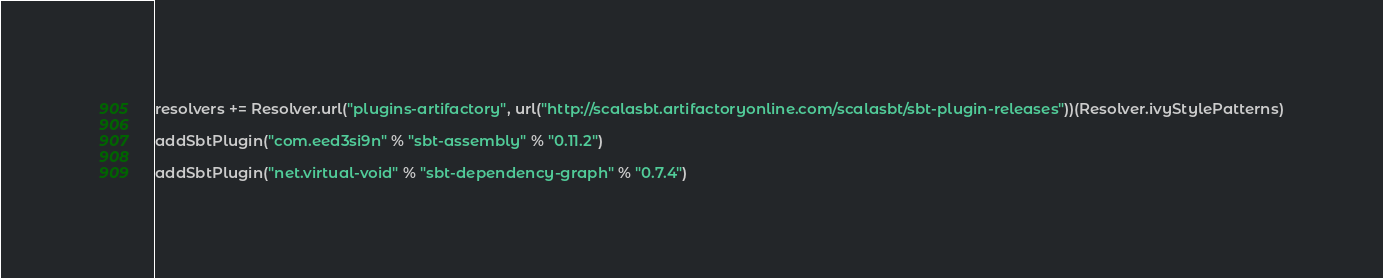Convert code to text. <code><loc_0><loc_0><loc_500><loc_500><_Scala_>resolvers += Resolver.url("plugins-artifactory", url("http://scalasbt.artifactoryonline.com/scalasbt/sbt-plugin-releases"))(Resolver.ivyStylePatterns)

addSbtPlugin("com.eed3si9n" % "sbt-assembly" % "0.11.2")

addSbtPlugin("net.virtual-void" % "sbt-dependency-graph" % "0.7.4")
</code> 